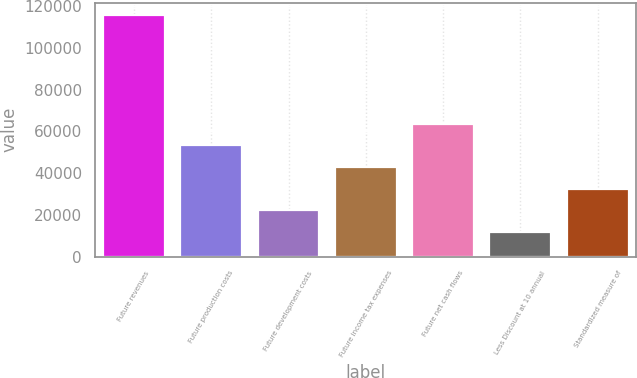Convert chart to OTSL. <chart><loc_0><loc_0><loc_500><loc_500><bar_chart><fcel>Future revenues<fcel>Future production costs<fcel>Future development costs<fcel>Future income tax expenses<fcel>Future net cash flows<fcel>Less Discount at 10 annual<fcel>Standardized measure of<nl><fcel>115826<fcel>53397.2<fcel>22182.8<fcel>42992.4<fcel>63802<fcel>11778<fcel>32587.6<nl></chart> 